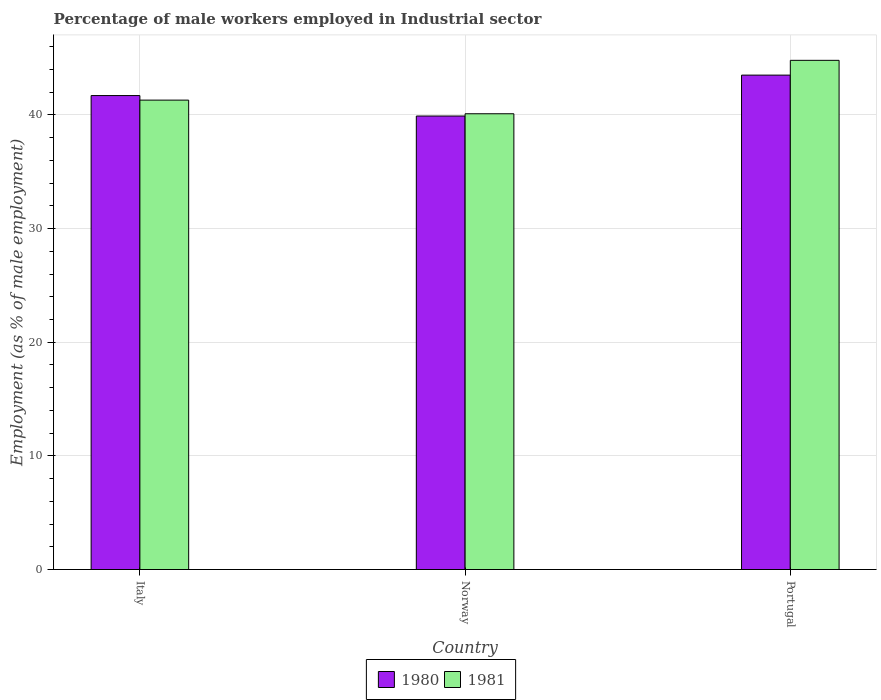How many groups of bars are there?
Keep it short and to the point. 3. Are the number of bars per tick equal to the number of legend labels?
Offer a terse response. Yes. Are the number of bars on each tick of the X-axis equal?
Your answer should be very brief. Yes. How many bars are there on the 2nd tick from the left?
Give a very brief answer. 2. How many bars are there on the 3rd tick from the right?
Offer a very short reply. 2. What is the percentage of male workers employed in Industrial sector in 1981 in Portugal?
Keep it short and to the point. 44.8. Across all countries, what is the maximum percentage of male workers employed in Industrial sector in 1980?
Provide a short and direct response. 43.5. Across all countries, what is the minimum percentage of male workers employed in Industrial sector in 1981?
Offer a very short reply. 40.1. What is the total percentage of male workers employed in Industrial sector in 1980 in the graph?
Make the answer very short. 125.1. What is the difference between the percentage of male workers employed in Industrial sector in 1980 in Italy and that in Portugal?
Your answer should be compact. -1.8. What is the difference between the percentage of male workers employed in Industrial sector in 1981 in Norway and the percentage of male workers employed in Industrial sector in 1980 in Italy?
Keep it short and to the point. -1.6. What is the average percentage of male workers employed in Industrial sector in 1980 per country?
Make the answer very short. 41.7. What is the difference between the percentage of male workers employed in Industrial sector of/in 1981 and percentage of male workers employed in Industrial sector of/in 1980 in Italy?
Ensure brevity in your answer.  -0.4. What is the ratio of the percentage of male workers employed in Industrial sector in 1980 in Italy to that in Portugal?
Your response must be concise. 0.96. What is the difference between the highest and the second highest percentage of male workers employed in Industrial sector in 1980?
Provide a succinct answer. -1.8. What is the difference between the highest and the lowest percentage of male workers employed in Industrial sector in 1981?
Your answer should be compact. 4.7. In how many countries, is the percentage of male workers employed in Industrial sector in 1981 greater than the average percentage of male workers employed in Industrial sector in 1981 taken over all countries?
Make the answer very short. 1. Is the sum of the percentage of male workers employed in Industrial sector in 1981 in Italy and Portugal greater than the maximum percentage of male workers employed in Industrial sector in 1980 across all countries?
Your response must be concise. Yes. What does the 1st bar from the right in Portugal represents?
Give a very brief answer. 1981. Are all the bars in the graph horizontal?
Offer a terse response. No. How many countries are there in the graph?
Make the answer very short. 3. What is the difference between two consecutive major ticks on the Y-axis?
Offer a terse response. 10. Does the graph contain any zero values?
Your answer should be compact. No. Does the graph contain grids?
Offer a very short reply. Yes. Where does the legend appear in the graph?
Ensure brevity in your answer.  Bottom center. How many legend labels are there?
Provide a succinct answer. 2. How are the legend labels stacked?
Offer a very short reply. Horizontal. What is the title of the graph?
Your answer should be compact. Percentage of male workers employed in Industrial sector. Does "2004" appear as one of the legend labels in the graph?
Provide a short and direct response. No. What is the label or title of the X-axis?
Your answer should be very brief. Country. What is the label or title of the Y-axis?
Offer a terse response. Employment (as % of male employment). What is the Employment (as % of male employment) of 1980 in Italy?
Make the answer very short. 41.7. What is the Employment (as % of male employment) of 1981 in Italy?
Provide a succinct answer. 41.3. What is the Employment (as % of male employment) in 1980 in Norway?
Your response must be concise. 39.9. What is the Employment (as % of male employment) in 1981 in Norway?
Keep it short and to the point. 40.1. What is the Employment (as % of male employment) in 1980 in Portugal?
Your answer should be compact. 43.5. What is the Employment (as % of male employment) in 1981 in Portugal?
Give a very brief answer. 44.8. Across all countries, what is the maximum Employment (as % of male employment) of 1980?
Offer a very short reply. 43.5. Across all countries, what is the maximum Employment (as % of male employment) in 1981?
Your answer should be compact. 44.8. Across all countries, what is the minimum Employment (as % of male employment) of 1980?
Ensure brevity in your answer.  39.9. Across all countries, what is the minimum Employment (as % of male employment) of 1981?
Give a very brief answer. 40.1. What is the total Employment (as % of male employment) in 1980 in the graph?
Ensure brevity in your answer.  125.1. What is the total Employment (as % of male employment) in 1981 in the graph?
Ensure brevity in your answer.  126.2. What is the difference between the Employment (as % of male employment) of 1980 in Italy and that in Norway?
Give a very brief answer. 1.8. What is the difference between the Employment (as % of male employment) in 1981 in Italy and that in Portugal?
Your answer should be very brief. -3.5. What is the difference between the Employment (as % of male employment) of 1981 in Norway and that in Portugal?
Ensure brevity in your answer.  -4.7. What is the difference between the Employment (as % of male employment) in 1980 in Norway and the Employment (as % of male employment) in 1981 in Portugal?
Your response must be concise. -4.9. What is the average Employment (as % of male employment) of 1980 per country?
Offer a terse response. 41.7. What is the average Employment (as % of male employment) in 1981 per country?
Provide a succinct answer. 42.07. What is the difference between the Employment (as % of male employment) of 1980 and Employment (as % of male employment) of 1981 in Italy?
Keep it short and to the point. 0.4. What is the difference between the Employment (as % of male employment) of 1980 and Employment (as % of male employment) of 1981 in Norway?
Your answer should be very brief. -0.2. What is the ratio of the Employment (as % of male employment) of 1980 in Italy to that in Norway?
Offer a very short reply. 1.05. What is the ratio of the Employment (as % of male employment) in 1981 in Italy to that in Norway?
Ensure brevity in your answer.  1.03. What is the ratio of the Employment (as % of male employment) in 1980 in Italy to that in Portugal?
Your answer should be compact. 0.96. What is the ratio of the Employment (as % of male employment) of 1981 in Italy to that in Portugal?
Your response must be concise. 0.92. What is the ratio of the Employment (as % of male employment) in 1980 in Norway to that in Portugal?
Give a very brief answer. 0.92. What is the ratio of the Employment (as % of male employment) of 1981 in Norway to that in Portugal?
Keep it short and to the point. 0.9. What is the difference between the highest and the second highest Employment (as % of male employment) of 1981?
Keep it short and to the point. 3.5. 